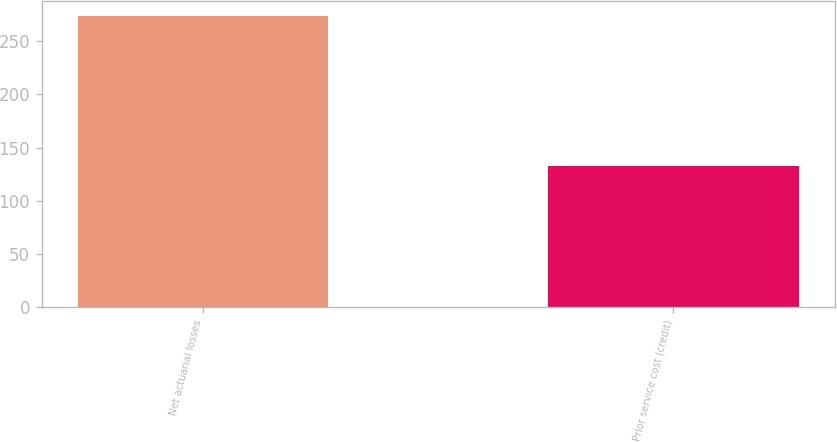<chart> <loc_0><loc_0><loc_500><loc_500><bar_chart><fcel>Net actuarial losses<fcel>Prior service cost (credit)<nl><fcel>274<fcel>133<nl></chart> 